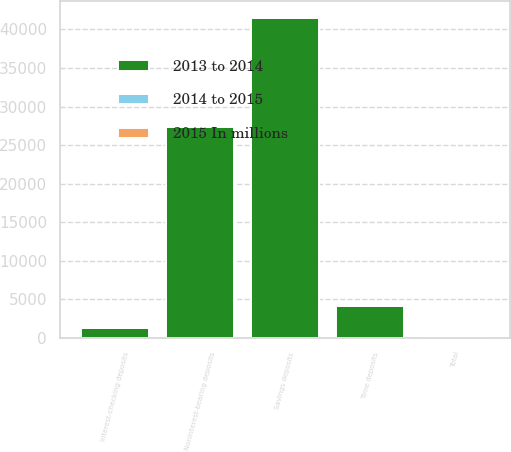Convert chart to OTSL. <chart><loc_0><loc_0><loc_500><loc_500><stacked_bar_chart><ecel><fcel>Interest-checking deposits<fcel>Savings deposits<fcel>Time deposits<fcel>Noninterest-bearing deposits<fcel>Total<nl><fcel>2013 to 2014<fcel>1250<fcel>41522<fcel>4103<fcel>27324<fcel>13.5<nl><fcel>2015 In millions<fcel>24<fcel>5<fcel>40<fcel>6<fcel>7<nl><fcel>2014 to 2015<fcel>12<fcel>10<fcel>15<fcel>8<fcel>8<nl></chart> 